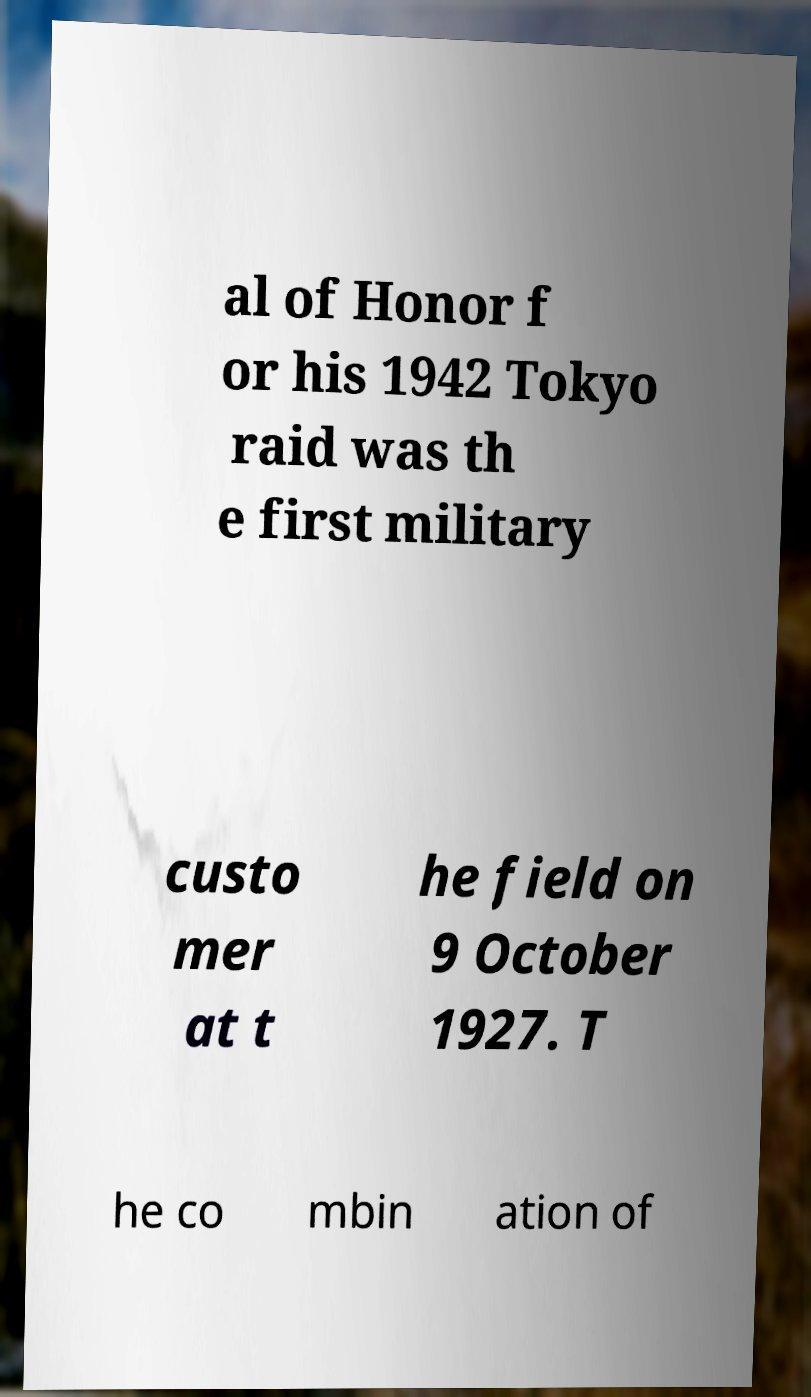Can you read and provide the text displayed in the image?This photo seems to have some interesting text. Can you extract and type it out for me? al of Honor f or his 1942 Tokyo raid was th e first military custo mer at t he field on 9 October 1927. T he co mbin ation of 